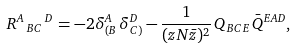<formula> <loc_0><loc_0><loc_500><loc_500>R ^ { A } { \, } _ { B C } { \, } ^ { D } = - 2 \delta _ { ( B } ^ { A } \, \delta _ { C ) } ^ { D } - \frac { 1 } { ( z N \bar { z } ) ^ { 2 } } \, Q _ { B C E } \, \bar { Q } ^ { E A D } ,</formula> 